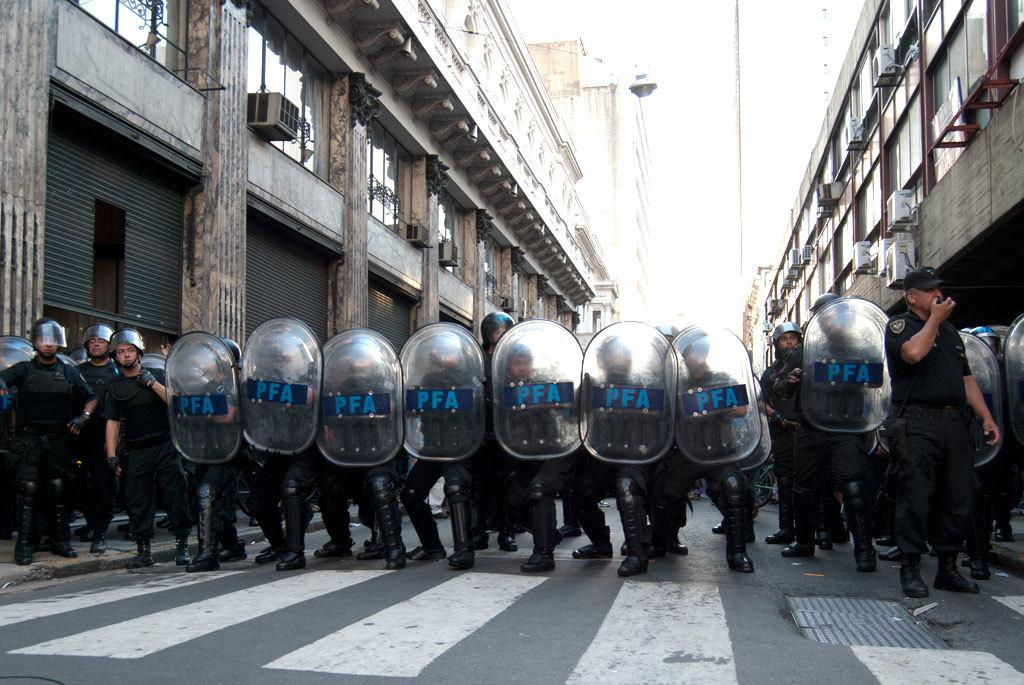Who or what is present in the image? There are people in the image. What are the people holding in their hands? The people are holding shields in their hands. What can be seen in the distance behind the people? There are buildings in the background of the image. What is at the bottom of the image? There is a road at the bottom of the image. Can you see any cobwebs hanging from the buildings in the image? There is no mention of cobwebs in the provided facts, so we cannot determine if any are present in the image. What type of meat is being served on the road in the image? There is no mention of meat or any food in the provided facts, so we cannot determine if any is present in the image. 